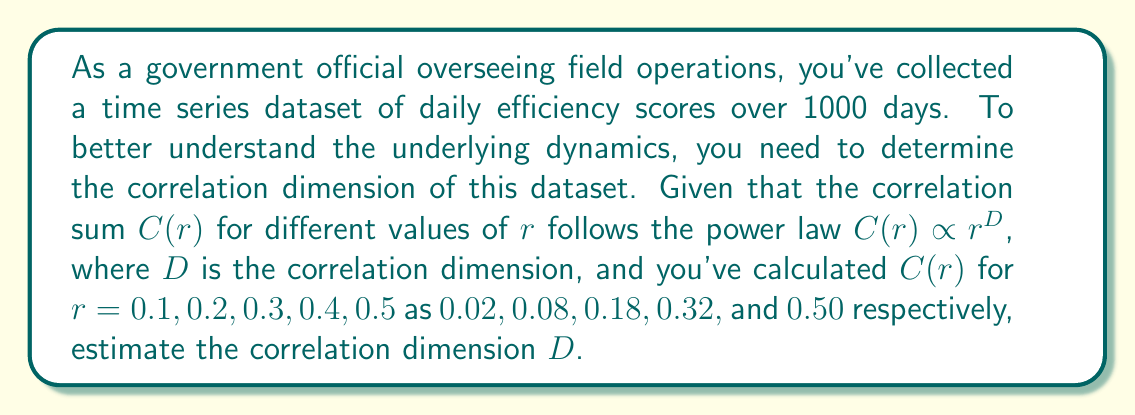Solve this math problem. To determine the correlation dimension D, we'll follow these steps:

1) The power law relationship is given by:
   $$C(r) \propto r^D$$

2) Taking logarithms on both sides:
   $$\log C(r) \propto D \log r$$

3) This suggests a linear relationship between $\log C(r)$ and $\log r$, where D is the slope.

4) Let's calculate $\log r$ and $\log C(r)$ for each data point:

   | r   | C(r) | log r       | log C(r)    |
   |-----|------|-------------|-------------|
   | 0.1 | 0.02 | -2.302585   | -3.912023   |
   | 0.2 | 0.08 | -1.609438   | -2.525729   |
   | 0.3 | 0.18 | -1.203973   | -1.714798   |
   | 0.4 | 0.32 | -0.916291   | -1.139434   |
   | 0.5 | 0.50 | -0.693147   | -0.693147   |

5) We can use the slope formula to estimate D:

   $$D \approx \frac{\log C(r_2) - \log C(r_1)}{\log r_2 - \log r_1}$$

6) Using the first and last points:

   $$D \approx \frac{-0.693147 - (-3.912023)}{-0.693147 - (-2.302585)}$$

7) Calculating:

   $$D \approx \frac{3.218876}{1.609438} \approx 2.000$$

Therefore, the estimated correlation dimension D is approximately 2.
Answer: D ≈ 2 